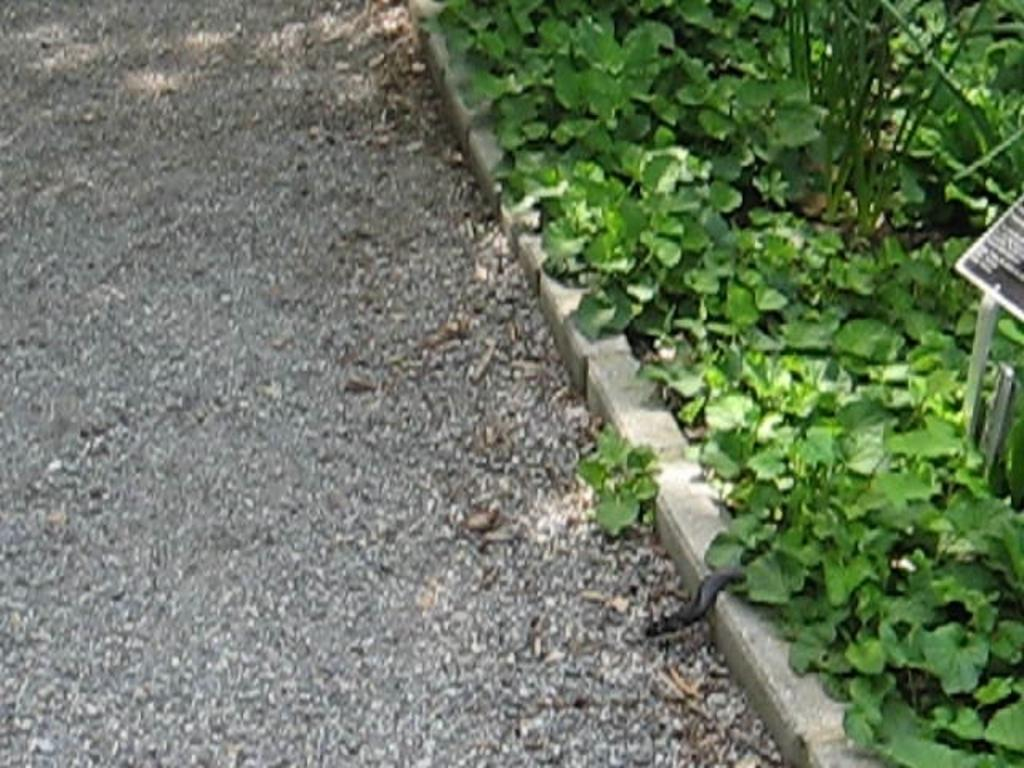What type of natural elements can be seen on the ground in the image? There are stones on the ground in the image. What type of living organisms are present in the image? There are plants in the image. Can you describe any other objects or features in the image? There are unspecified objects in the image. What type of juice is being served in the image? There is no juice present in the image. How many trucks can be seen in the image? There are no trucks present in the image. 